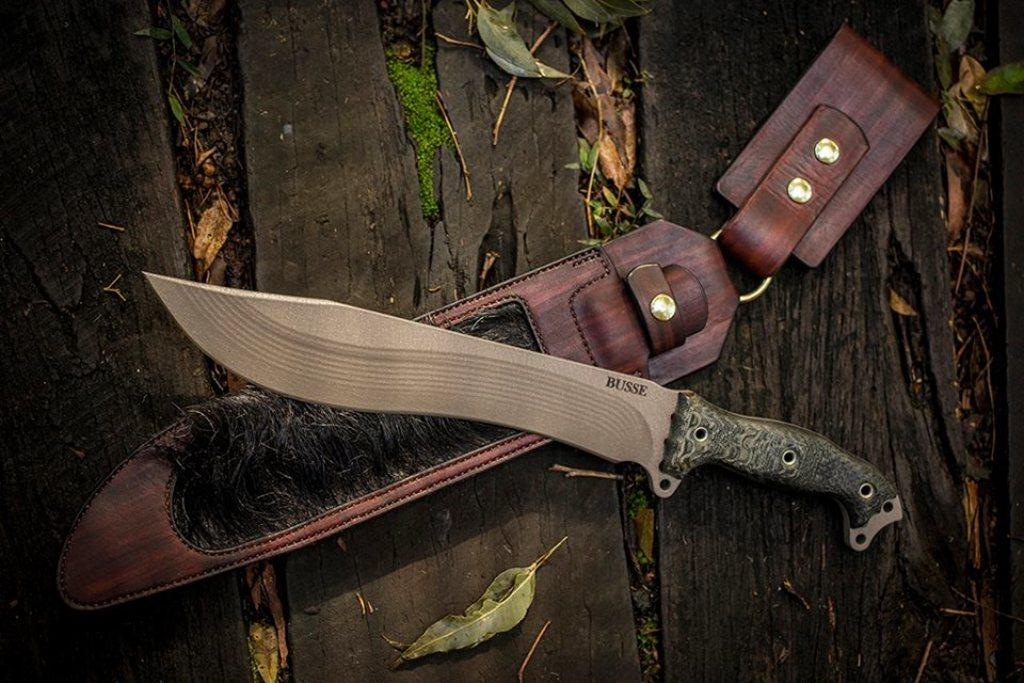What object is located in the center of the image? There is a knife in the center of the image. What is the knife holder used for? The knife holder is used for storing the knife when it is not in use. What type of material can be seen in the background of the image? There is wood in the background of the image. What natural elements are present in the background of the image? Dry leaves are present in the background of the image. How does the pet interact with the visitor in the image? There is no pet or visitor present in the image; it only features a knife and a knife holder. 